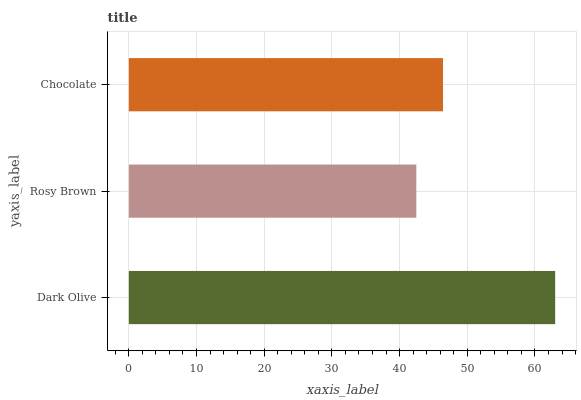Is Rosy Brown the minimum?
Answer yes or no. Yes. Is Dark Olive the maximum?
Answer yes or no. Yes. Is Chocolate the minimum?
Answer yes or no. No. Is Chocolate the maximum?
Answer yes or no. No. Is Chocolate greater than Rosy Brown?
Answer yes or no. Yes. Is Rosy Brown less than Chocolate?
Answer yes or no. Yes. Is Rosy Brown greater than Chocolate?
Answer yes or no. No. Is Chocolate less than Rosy Brown?
Answer yes or no. No. Is Chocolate the high median?
Answer yes or no. Yes. Is Chocolate the low median?
Answer yes or no. Yes. Is Rosy Brown the high median?
Answer yes or no. No. Is Dark Olive the low median?
Answer yes or no. No. 